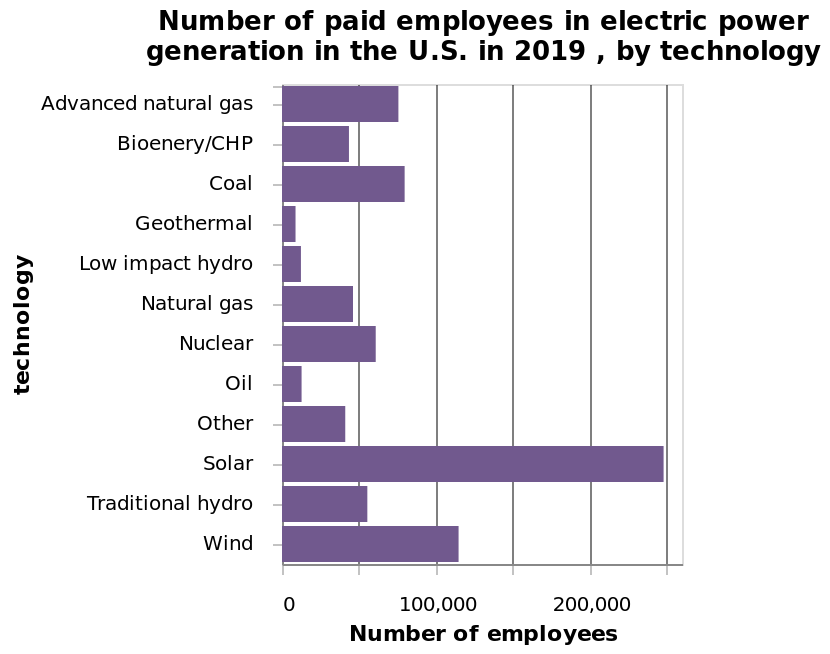<image>
please enumerates aspects of the construction of the chart This is a bar plot titled Number of paid employees in electric power generation in the U.S. in 2019 , by technology. A linear scale from 0 to 250,000 can be seen along the x-axis, marked Number of employees. The y-axis shows technology. What is shown on the x-axis of the bar plot? The x-axis of the bar plot is marked as "Number of employees" and ranges from 0 to 250,000 on a linear scale. Which renewable energy sources have the highest number of paid employees?  Solar and wind energy have the highest number of paid employees. Which renewable energy source has the lowest number of paid employees?  Geothermal energy has the lowest number of paid employees. Offer a thorough analysis of the image. Solar Technology employs the highest number of people in electric power generation. The number of employees in Solar (250,000) is 2.5 times the number employed in the next highest, which is Wind (100,000).Geothermal employees the least number of people. please summary the statistics and relations of the chart solar and wind have the highest number of paid employees. geothermal has the lowest number of paid employees. rest of the catergories are evenly distributed. Do nuclear and coal energy have the highest number of paid employees? No. Solar and wind energy have the highest number of paid employees. 